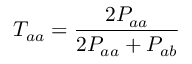<formula> <loc_0><loc_0><loc_500><loc_500>T _ { a a } = \frac { 2 P _ { a a } } { 2 P _ { a a } + P _ { a b } }</formula> 